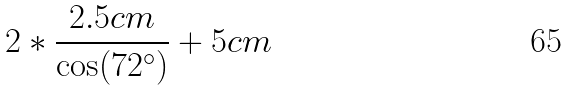<formula> <loc_0><loc_0><loc_500><loc_500>2 * \frac { 2 . 5 c m } { \cos ( 7 2 ^ { \circ } ) } + 5 c m</formula> 